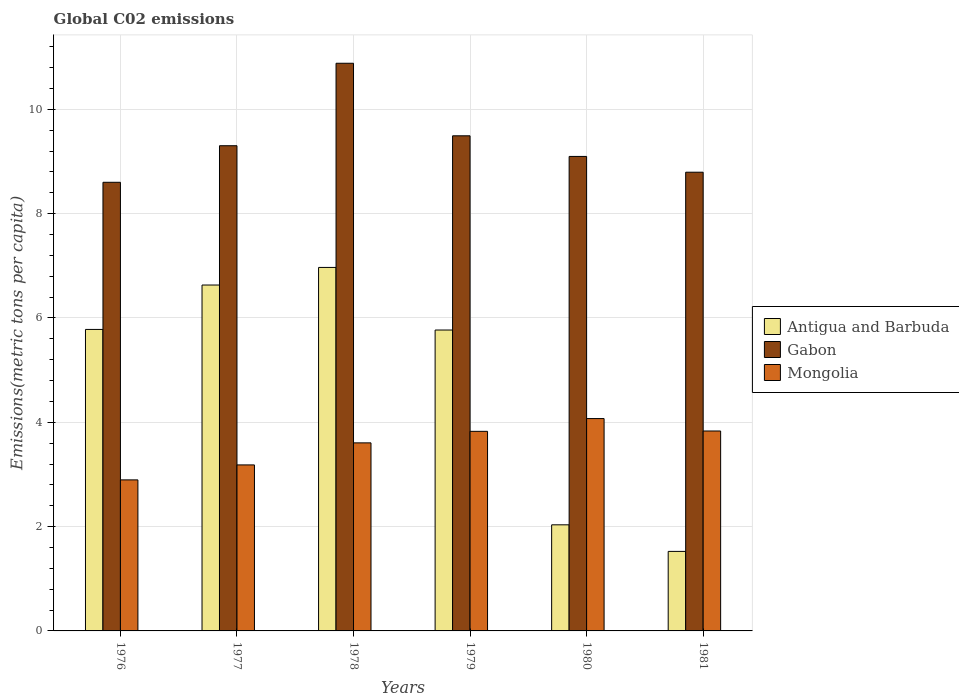What is the label of the 4th group of bars from the left?
Your answer should be very brief. 1979. What is the amount of CO2 emitted in in Mongolia in 1977?
Keep it short and to the point. 3.18. Across all years, what is the maximum amount of CO2 emitted in in Gabon?
Make the answer very short. 10.88. Across all years, what is the minimum amount of CO2 emitted in in Gabon?
Your answer should be compact. 8.6. In which year was the amount of CO2 emitted in in Mongolia maximum?
Offer a very short reply. 1980. In which year was the amount of CO2 emitted in in Gabon minimum?
Your answer should be very brief. 1976. What is the total amount of CO2 emitted in in Mongolia in the graph?
Your response must be concise. 21.42. What is the difference between the amount of CO2 emitted in in Gabon in 1977 and that in 1978?
Provide a succinct answer. -1.58. What is the difference between the amount of CO2 emitted in in Antigua and Barbuda in 1977 and the amount of CO2 emitted in in Mongolia in 1979?
Ensure brevity in your answer.  2.81. What is the average amount of CO2 emitted in in Antigua and Barbuda per year?
Provide a succinct answer. 4.78. In the year 1977, what is the difference between the amount of CO2 emitted in in Gabon and amount of CO2 emitted in in Antigua and Barbuda?
Give a very brief answer. 2.67. In how many years, is the amount of CO2 emitted in in Gabon greater than 3.2 metric tons per capita?
Keep it short and to the point. 6. What is the ratio of the amount of CO2 emitted in in Antigua and Barbuda in 1979 to that in 1980?
Your answer should be compact. 2.84. Is the amount of CO2 emitted in in Antigua and Barbuda in 1979 less than that in 1981?
Your answer should be very brief. No. What is the difference between the highest and the second highest amount of CO2 emitted in in Gabon?
Your answer should be compact. 1.39. What is the difference between the highest and the lowest amount of CO2 emitted in in Mongolia?
Make the answer very short. 1.18. Is the sum of the amount of CO2 emitted in in Mongolia in 1979 and 1981 greater than the maximum amount of CO2 emitted in in Antigua and Barbuda across all years?
Make the answer very short. Yes. What does the 1st bar from the left in 1976 represents?
Your answer should be compact. Antigua and Barbuda. What does the 2nd bar from the right in 1978 represents?
Offer a terse response. Gabon. Is it the case that in every year, the sum of the amount of CO2 emitted in in Gabon and amount of CO2 emitted in in Antigua and Barbuda is greater than the amount of CO2 emitted in in Mongolia?
Provide a short and direct response. Yes. How many bars are there?
Give a very brief answer. 18. Are the values on the major ticks of Y-axis written in scientific E-notation?
Your response must be concise. No. Does the graph contain any zero values?
Your response must be concise. No. Where does the legend appear in the graph?
Keep it short and to the point. Center right. How are the legend labels stacked?
Give a very brief answer. Vertical. What is the title of the graph?
Make the answer very short. Global C02 emissions. Does "Low income" appear as one of the legend labels in the graph?
Ensure brevity in your answer.  No. What is the label or title of the X-axis?
Your answer should be compact. Years. What is the label or title of the Y-axis?
Your answer should be very brief. Emissions(metric tons per capita). What is the Emissions(metric tons per capita) in Antigua and Barbuda in 1976?
Provide a succinct answer. 5.78. What is the Emissions(metric tons per capita) in Gabon in 1976?
Offer a terse response. 8.6. What is the Emissions(metric tons per capita) of Mongolia in 1976?
Provide a succinct answer. 2.9. What is the Emissions(metric tons per capita) in Antigua and Barbuda in 1977?
Offer a terse response. 6.63. What is the Emissions(metric tons per capita) of Gabon in 1977?
Keep it short and to the point. 9.3. What is the Emissions(metric tons per capita) in Mongolia in 1977?
Make the answer very short. 3.18. What is the Emissions(metric tons per capita) in Antigua and Barbuda in 1978?
Your answer should be very brief. 6.97. What is the Emissions(metric tons per capita) of Gabon in 1978?
Provide a succinct answer. 10.88. What is the Emissions(metric tons per capita) of Mongolia in 1978?
Your answer should be compact. 3.61. What is the Emissions(metric tons per capita) of Antigua and Barbuda in 1979?
Your answer should be very brief. 5.77. What is the Emissions(metric tons per capita) in Gabon in 1979?
Your answer should be very brief. 9.49. What is the Emissions(metric tons per capita) in Mongolia in 1979?
Make the answer very short. 3.83. What is the Emissions(metric tons per capita) of Antigua and Barbuda in 1980?
Your response must be concise. 2.03. What is the Emissions(metric tons per capita) in Gabon in 1980?
Make the answer very short. 9.1. What is the Emissions(metric tons per capita) of Mongolia in 1980?
Give a very brief answer. 4.07. What is the Emissions(metric tons per capita) of Antigua and Barbuda in 1981?
Your answer should be very brief. 1.52. What is the Emissions(metric tons per capita) of Gabon in 1981?
Offer a terse response. 8.79. What is the Emissions(metric tons per capita) in Mongolia in 1981?
Ensure brevity in your answer.  3.83. Across all years, what is the maximum Emissions(metric tons per capita) of Antigua and Barbuda?
Give a very brief answer. 6.97. Across all years, what is the maximum Emissions(metric tons per capita) of Gabon?
Ensure brevity in your answer.  10.88. Across all years, what is the maximum Emissions(metric tons per capita) in Mongolia?
Provide a succinct answer. 4.07. Across all years, what is the minimum Emissions(metric tons per capita) in Antigua and Barbuda?
Offer a terse response. 1.52. Across all years, what is the minimum Emissions(metric tons per capita) in Gabon?
Your answer should be very brief. 8.6. Across all years, what is the minimum Emissions(metric tons per capita) of Mongolia?
Your answer should be compact. 2.9. What is the total Emissions(metric tons per capita) of Antigua and Barbuda in the graph?
Make the answer very short. 28.71. What is the total Emissions(metric tons per capita) of Gabon in the graph?
Provide a succinct answer. 56.17. What is the total Emissions(metric tons per capita) of Mongolia in the graph?
Offer a terse response. 21.42. What is the difference between the Emissions(metric tons per capita) of Antigua and Barbuda in 1976 and that in 1977?
Your answer should be very brief. -0.85. What is the difference between the Emissions(metric tons per capita) in Gabon in 1976 and that in 1977?
Provide a short and direct response. -0.7. What is the difference between the Emissions(metric tons per capita) of Mongolia in 1976 and that in 1977?
Provide a succinct answer. -0.29. What is the difference between the Emissions(metric tons per capita) of Antigua and Barbuda in 1976 and that in 1978?
Your answer should be compact. -1.19. What is the difference between the Emissions(metric tons per capita) of Gabon in 1976 and that in 1978?
Provide a short and direct response. -2.28. What is the difference between the Emissions(metric tons per capita) of Mongolia in 1976 and that in 1978?
Offer a very short reply. -0.71. What is the difference between the Emissions(metric tons per capita) of Antigua and Barbuda in 1976 and that in 1979?
Offer a terse response. 0.01. What is the difference between the Emissions(metric tons per capita) of Gabon in 1976 and that in 1979?
Give a very brief answer. -0.89. What is the difference between the Emissions(metric tons per capita) of Mongolia in 1976 and that in 1979?
Your answer should be compact. -0.93. What is the difference between the Emissions(metric tons per capita) in Antigua and Barbuda in 1976 and that in 1980?
Provide a succinct answer. 3.75. What is the difference between the Emissions(metric tons per capita) in Gabon in 1976 and that in 1980?
Your answer should be very brief. -0.5. What is the difference between the Emissions(metric tons per capita) of Mongolia in 1976 and that in 1980?
Your answer should be compact. -1.18. What is the difference between the Emissions(metric tons per capita) of Antigua and Barbuda in 1976 and that in 1981?
Make the answer very short. 4.26. What is the difference between the Emissions(metric tons per capita) in Gabon in 1976 and that in 1981?
Your answer should be compact. -0.19. What is the difference between the Emissions(metric tons per capita) of Mongolia in 1976 and that in 1981?
Your response must be concise. -0.94. What is the difference between the Emissions(metric tons per capita) of Antigua and Barbuda in 1977 and that in 1978?
Your answer should be compact. -0.34. What is the difference between the Emissions(metric tons per capita) in Gabon in 1977 and that in 1978?
Make the answer very short. -1.58. What is the difference between the Emissions(metric tons per capita) in Mongolia in 1977 and that in 1978?
Your answer should be compact. -0.42. What is the difference between the Emissions(metric tons per capita) in Antigua and Barbuda in 1977 and that in 1979?
Make the answer very short. 0.86. What is the difference between the Emissions(metric tons per capita) in Gabon in 1977 and that in 1979?
Offer a terse response. -0.19. What is the difference between the Emissions(metric tons per capita) of Mongolia in 1977 and that in 1979?
Make the answer very short. -0.64. What is the difference between the Emissions(metric tons per capita) in Antigua and Barbuda in 1977 and that in 1980?
Keep it short and to the point. 4.6. What is the difference between the Emissions(metric tons per capita) of Gabon in 1977 and that in 1980?
Offer a very short reply. 0.21. What is the difference between the Emissions(metric tons per capita) of Mongolia in 1977 and that in 1980?
Keep it short and to the point. -0.89. What is the difference between the Emissions(metric tons per capita) of Antigua and Barbuda in 1977 and that in 1981?
Your answer should be very brief. 5.11. What is the difference between the Emissions(metric tons per capita) of Gabon in 1977 and that in 1981?
Keep it short and to the point. 0.51. What is the difference between the Emissions(metric tons per capita) in Mongolia in 1977 and that in 1981?
Ensure brevity in your answer.  -0.65. What is the difference between the Emissions(metric tons per capita) of Antigua and Barbuda in 1978 and that in 1979?
Ensure brevity in your answer.  1.2. What is the difference between the Emissions(metric tons per capita) of Gabon in 1978 and that in 1979?
Offer a terse response. 1.39. What is the difference between the Emissions(metric tons per capita) in Mongolia in 1978 and that in 1979?
Make the answer very short. -0.22. What is the difference between the Emissions(metric tons per capita) of Antigua and Barbuda in 1978 and that in 1980?
Make the answer very short. 4.93. What is the difference between the Emissions(metric tons per capita) in Gabon in 1978 and that in 1980?
Ensure brevity in your answer.  1.79. What is the difference between the Emissions(metric tons per capita) in Mongolia in 1978 and that in 1980?
Ensure brevity in your answer.  -0.47. What is the difference between the Emissions(metric tons per capita) in Antigua and Barbuda in 1978 and that in 1981?
Your answer should be compact. 5.44. What is the difference between the Emissions(metric tons per capita) in Gabon in 1978 and that in 1981?
Give a very brief answer. 2.09. What is the difference between the Emissions(metric tons per capita) of Mongolia in 1978 and that in 1981?
Offer a terse response. -0.23. What is the difference between the Emissions(metric tons per capita) of Antigua and Barbuda in 1979 and that in 1980?
Give a very brief answer. 3.73. What is the difference between the Emissions(metric tons per capita) of Gabon in 1979 and that in 1980?
Give a very brief answer. 0.4. What is the difference between the Emissions(metric tons per capita) in Mongolia in 1979 and that in 1980?
Your response must be concise. -0.24. What is the difference between the Emissions(metric tons per capita) in Antigua and Barbuda in 1979 and that in 1981?
Keep it short and to the point. 4.24. What is the difference between the Emissions(metric tons per capita) in Gabon in 1979 and that in 1981?
Provide a short and direct response. 0.7. What is the difference between the Emissions(metric tons per capita) in Mongolia in 1979 and that in 1981?
Offer a terse response. -0.01. What is the difference between the Emissions(metric tons per capita) in Antigua and Barbuda in 1980 and that in 1981?
Your response must be concise. 0.51. What is the difference between the Emissions(metric tons per capita) of Gabon in 1980 and that in 1981?
Provide a short and direct response. 0.3. What is the difference between the Emissions(metric tons per capita) of Mongolia in 1980 and that in 1981?
Give a very brief answer. 0.24. What is the difference between the Emissions(metric tons per capita) of Antigua and Barbuda in 1976 and the Emissions(metric tons per capita) of Gabon in 1977?
Give a very brief answer. -3.52. What is the difference between the Emissions(metric tons per capita) in Antigua and Barbuda in 1976 and the Emissions(metric tons per capita) in Mongolia in 1977?
Your answer should be very brief. 2.6. What is the difference between the Emissions(metric tons per capita) in Gabon in 1976 and the Emissions(metric tons per capita) in Mongolia in 1977?
Ensure brevity in your answer.  5.42. What is the difference between the Emissions(metric tons per capita) in Antigua and Barbuda in 1976 and the Emissions(metric tons per capita) in Gabon in 1978?
Keep it short and to the point. -5.1. What is the difference between the Emissions(metric tons per capita) in Antigua and Barbuda in 1976 and the Emissions(metric tons per capita) in Mongolia in 1978?
Provide a succinct answer. 2.17. What is the difference between the Emissions(metric tons per capita) in Gabon in 1976 and the Emissions(metric tons per capita) in Mongolia in 1978?
Give a very brief answer. 5. What is the difference between the Emissions(metric tons per capita) of Antigua and Barbuda in 1976 and the Emissions(metric tons per capita) of Gabon in 1979?
Give a very brief answer. -3.71. What is the difference between the Emissions(metric tons per capita) of Antigua and Barbuda in 1976 and the Emissions(metric tons per capita) of Mongolia in 1979?
Provide a succinct answer. 1.95. What is the difference between the Emissions(metric tons per capita) of Gabon in 1976 and the Emissions(metric tons per capita) of Mongolia in 1979?
Your answer should be compact. 4.77. What is the difference between the Emissions(metric tons per capita) in Antigua and Barbuda in 1976 and the Emissions(metric tons per capita) in Gabon in 1980?
Your answer should be compact. -3.32. What is the difference between the Emissions(metric tons per capita) of Antigua and Barbuda in 1976 and the Emissions(metric tons per capita) of Mongolia in 1980?
Your answer should be compact. 1.71. What is the difference between the Emissions(metric tons per capita) in Gabon in 1976 and the Emissions(metric tons per capita) in Mongolia in 1980?
Ensure brevity in your answer.  4.53. What is the difference between the Emissions(metric tons per capita) of Antigua and Barbuda in 1976 and the Emissions(metric tons per capita) of Gabon in 1981?
Your response must be concise. -3.01. What is the difference between the Emissions(metric tons per capita) in Antigua and Barbuda in 1976 and the Emissions(metric tons per capita) in Mongolia in 1981?
Your answer should be very brief. 1.95. What is the difference between the Emissions(metric tons per capita) in Gabon in 1976 and the Emissions(metric tons per capita) in Mongolia in 1981?
Your answer should be very brief. 4.77. What is the difference between the Emissions(metric tons per capita) of Antigua and Barbuda in 1977 and the Emissions(metric tons per capita) of Gabon in 1978?
Offer a terse response. -4.25. What is the difference between the Emissions(metric tons per capita) in Antigua and Barbuda in 1977 and the Emissions(metric tons per capita) in Mongolia in 1978?
Provide a succinct answer. 3.03. What is the difference between the Emissions(metric tons per capita) of Gabon in 1977 and the Emissions(metric tons per capita) of Mongolia in 1978?
Provide a short and direct response. 5.7. What is the difference between the Emissions(metric tons per capita) in Antigua and Barbuda in 1977 and the Emissions(metric tons per capita) in Gabon in 1979?
Your answer should be very brief. -2.86. What is the difference between the Emissions(metric tons per capita) in Antigua and Barbuda in 1977 and the Emissions(metric tons per capita) in Mongolia in 1979?
Provide a succinct answer. 2.81. What is the difference between the Emissions(metric tons per capita) of Gabon in 1977 and the Emissions(metric tons per capita) of Mongolia in 1979?
Offer a terse response. 5.48. What is the difference between the Emissions(metric tons per capita) of Antigua and Barbuda in 1977 and the Emissions(metric tons per capita) of Gabon in 1980?
Give a very brief answer. -2.47. What is the difference between the Emissions(metric tons per capita) in Antigua and Barbuda in 1977 and the Emissions(metric tons per capita) in Mongolia in 1980?
Offer a terse response. 2.56. What is the difference between the Emissions(metric tons per capita) in Gabon in 1977 and the Emissions(metric tons per capita) in Mongolia in 1980?
Your answer should be compact. 5.23. What is the difference between the Emissions(metric tons per capita) of Antigua and Barbuda in 1977 and the Emissions(metric tons per capita) of Gabon in 1981?
Offer a very short reply. -2.16. What is the difference between the Emissions(metric tons per capita) in Antigua and Barbuda in 1977 and the Emissions(metric tons per capita) in Mongolia in 1981?
Offer a terse response. 2.8. What is the difference between the Emissions(metric tons per capita) in Gabon in 1977 and the Emissions(metric tons per capita) in Mongolia in 1981?
Make the answer very short. 5.47. What is the difference between the Emissions(metric tons per capita) of Antigua and Barbuda in 1978 and the Emissions(metric tons per capita) of Gabon in 1979?
Provide a short and direct response. -2.52. What is the difference between the Emissions(metric tons per capita) in Antigua and Barbuda in 1978 and the Emissions(metric tons per capita) in Mongolia in 1979?
Give a very brief answer. 3.14. What is the difference between the Emissions(metric tons per capita) in Gabon in 1978 and the Emissions(metric tons per capita) in Mongolia in 1979?
Ensure brevity in your answer.  7.06. What is the difference between the Emissions(metric tons per capita) of Antigua and Barbuda in 1978 and the Emissions(metric tons per capita) of Gabon in 1980?
Your response must be concise. -2.13. What is the difference between the Emissions(metric tons per capita) of Antigua and Barbuda in 1978 and the Emissions(metric tons per capita) of Mongolia in 1980?
Give a very brief answer. 2.9. What is the difference between the Emissions(metric tons per capita) of Gabon in 1978 and the Emissions(metric tons per capita) of Mongolia in 1980?
Keep it short and to the point. 6.81. What is the difference between the Emissions(metric tons per capita) in Antigua and Barbuda in 1978 and the Emissions(metric tons per capita) in Gabon in 1981?
Offer a terse response. -1.83. What is the difference between the Emissions(metric tons per capita) in Antigua and Barbuda in 1978 and the Emissions(metric tons per capita) in Mongolia in 1981?
Make the answer very short. 3.14. What is the difference between the Emissions(metric tons per capita) of Gabon in 1978 and the Emissions(metric tons per capita) of Mongolia in 1981?
Offer a very short reply. 7.05. What is the difference between the Emissions(metric tons per capita) of Antigua and Barbuda in 1979 and the Emissions(metric tons per capita) of Gabon in 1980?
Ensure brevity in your answer.  -3.33. What is the difference between the Emissions(metric tons per capita) in Antigua and Barbuda in 1979 and the Emissions(metric tons per capita) in Mongolia in 1980?
Ensure brevity in your answer.  1.7. What is the difference between the Emissions(metric tons per capita) of Gabon in 1979 and the Emissions(metric tons per capita) of Mongolia in 1980?
Provide a succinct answer. 5.42. What is the difference between the Emissions(metric tons per capita) of Antigua and Barbuda in 1979 and the Emissions(metric tons per capita) of Gabon in 1981?
Make the answer very short. -3.03. What is the difference between the Emissions(metric tons per capita) of Antigua and Barbuda in 1979 and the Emissions(metric tons per capita) of Mongolia in 1981?
Make the answer very short. 1.94. What is the difference between the Emissions(metric tons per capita) of Gabon in 1979 and the Emissions(metric tons per capita) of Mongolia in 1981?
Make the answer very short. 5.66. What is the difference between the Emissions(metric tons per capita) in Antigua and Barbuda in 1980 and the Emissions(metric tons per capita) in Gabon in 1981?
Your answer should be very brief. -6.76. What is the difference between the Emissions(metric tons per capita) in Antigua and Barbuda in 1980 and the Emissions(metric tons per capita) in Mongolia in 1981?
Offer a very short reply. -1.8. What is the difference between the Emissions(metric tons per capita) in Gabon in 1980 and the Emissions(metric tons per capita) in Mongolia in 1981?
Your response must be concise. 5.26. What is the average Emissions(metric tons per capita) in Antigua and Barbuda per year?
Offer a very short reply. 4.78. What is the average Emissions(metric tons per capita) of Gabon per year?
Your answer should be compact. 9.36. What is the average Emissions(metric tons per capita) in Mongolia per year?
Your response must be concise. 3.57. In the year 1976, what is the difference between the Emissions(metric tons per capita) of Antigua and Barbuda and Emissions(metric tons per capita) of Gabon?
Offer a very short reply. -2.82. In the year 1976, what is the difference between the Emissions(metric tons per capita) of Antigua and Barbuda and Emissions(metric tons per capita) of Mongolia?
Offer a very short reply. 2.88. In the year 1976, what is the difference between the Emissions(metric tons per capita) in Gabon and Emissions(metric tons per capita) in Mongolia?
Your answer should be very brief. 5.71. In the year 1977, what is the difference between the Emissions(metric tons per capita) in Antigua and Barbuda and Emissions(metric tons per capita) in Gabon?
Keep it short and to the point. -2.67. In the year 1977, what is the difference between the Emissions(metric tons per capita) in Antigua and Barbuda and Emissions(metric tons per capita) in Mongolia?
Make the answer very short. 3.45. In the year 1977, what is the difference between the Emissions(metric tons per capita) in Gabon and Emissions(metric tons per capita) in Mongolia?
Give a very brief answer. 6.12. In the year 1978, what is the difference between the Emissions(metric tons per capita) in Antigua and Barbuda and Emissions(metric tons per capita) in Gabon?
Your response must be concise. -3.91. In the year 1978, what is the difference between the Emissions(metric tons per capita) of Antigua and Barbuda and Emissions(metric tons per capita) of Mongolia?
Offer a terse response. 3.36. In the year 1978, what is the difference between the Emissions(metric tons per capita) of Gabon and Emissions(metric tons per capita) of Mongolia?
Ensure brevity in your answer.  7.28. In the year 1979, what is the difference between the Emissions(metric tons per capita) in Antigua and Barbuda and Emissions(metric tons per capita) in Gabon?
Offer a very short reply. -3.72. In the year 1979, what is the difference between the Emissions(metric tons per capita) in Antigua and Barbuda and Emissions(metric tons per capita) in Mongolia?
Give a very brief answer. 1.94. In the year 1979, what is the difference between the Emissions(metric tons per capita) of Gabon and Emissions(metric tons per capita) of Mongolia?
Your answer should be compact. 5.67. In the year 1980, what is the difference between the Emissions(metric tons per capita) of Antigua and Barbuda and Emissions(metric tons per capita) of Gabon?
Offer a terse response. -7.06. In the year 1980, what is the difference between the Emissions(metric tons per capita) of Antigua and Barbuda and Emissions(metric tons per capita) of Mongolia?
Offer a very short reply. -2.04. In the year 1980, what is the difference between the Emissions(metric tons per capita) in Gabon and Emissions(metric tons per capita) in Mongolia?
Provide a short and direct response. 5.03. In the year 1981, what is the difference between the Emissions(metric tons per capita) of Antigua and Barbuda and Emissions(metric tons per capita) of Gabon?
Your answer should be compact. -7.27. In the year 1981, what is the difference between the Emissions(metric tons per capita) of Antigua and Barbuda and Emissions(metric tons per capita) of Mongolia?
Provide a short and direct response. -2.31. In the year 1981, what is the difference between the Emissions(metric tons per capita) of Gabon and Emissions(metric tons per capita) of Mongolia?
Your answer should be compact. 4.96. What is the ratio of the Emissions(metric tons per capita) in Antigua and Barbuda in 1976 to that in 1977?
Give a very brief answer. 0.87. What is the ratio of the Emissions(metric tons per capita) in Gabon in 1976 to that in 1977?
Your response must be concise. 0.92. What is the ratio of the Emissions(metric tons per capita) in Mongolia in 1976 to that in 1977?
Keep it short and to the point. 0.91. What is the ratio of the Emissions(metric tons per capita) in Antigua and Barbuda in 1976 to that in 1978?
Offer a terse response. 0.83. What is the ratio of the Emissions(metric tons per capita) of Gabon in 1976 to that in 1978?
Offer a terse response. 0.79. What is the ratio of the Emissions(metric tons per capita) in Mongolia in 1976 to that in 1978?
Offer a terse response. 0.8. What is the ratio of the Emissions(metric tons per capita) in Gabon in 1976 to that in 1979?
Offer a terse response. 0.91. What is the ratio of the Emissions(metric tons per capita) of Mongolia in 1976 to that in 1979?
Make the answer very short. 0.76. What is the ratio of the Emissions(metric tons per capita) in Antigua and Barbuda in 1976 to that in 1980?
Make the answer very short. 2.84. What is the ratio of the Emissions(metric tons per capita) of Gabon in 1976 to that in 1980?
Offer a terse response. 0.95. What is the ratio of the Emissions(metric tons per capita) of Mongolia in 1976 to that in 1980?
Your answer should be very brief. 0.71. What is the ratio of the Emissions(metric tons per capita) of Antigua and Barbuda in 1976 to that in 1981?
Your response must be concise. 3.79. What is the ratio of the Emissions(metric tons per capita) of Mongolia in 1976 to that in 1981?
Your answer should be very brief. 0.76. What is the ratio of the Emissions(metric tons per capita) of Antigua and Barbuda in 1977 to that in 1978?
Ensure brevity in your answer.  0.95. What is the ratio of the Emissions(metric tons per capita) in Gabon in 1977 to that in 1978?
Your response must be concise. 0.85. What is the ratio of the Emissions(metric tons per capita) of Mongolia in 1977 to that in 1978?
Offer a terse response. 0.88. What is the ratio of the Emissions(metric tons per capita) of Antigua and Barbuda in 1977 to that in 1979?
Keep it short and to the point. 1.15. What is the ratio of the Emissions(metric tons per capita) of Gabon in 1977 to that in 1979?
Give a very brief answer. 0.98. What is the ratio of the Emissions(metric tons per capita) in Mongolia in 1977 to that in 1979?
Make the answer very short. 0.83. What is the ratio of the Emissions(metric tons per capita) in Antigua and Barbuda in 1977 to that in 1980?
Offer a very short reply. 3.26. What is the ratio of the Emissions(metric tons per capita) in Gabon in 1977 to that in 1980?
Make the answer very short. 1.02. What is the ratio of the Emissions(metric tons per capita) of Mongolia in 1977 to that in 1980?
Provide a succinct answer. 0.78. What is the ratio of the Emissions(metric tons per capita) in Antigua and Barbuda in 1977 to that in 1981?
Ensure brevity in your answer.  4.35. What is the ratio of the Emissions(metric tons per capita) of Gabon in 1977 to that in 1981?
Make the answer very short. 1.06. What is the ratio of the Emissions(metric tons per capita) of Mongolia in 1977 to that in 1981?
Your answer should be compact. 0.83. What is the ratio of the Emissions(metric tons per capita) in Antigua and Barbuda in 1978 to that in 1979?
Your answer should be very brief. 1.21. What is the ratio of the Emissions(metric tons per capita) in Gabon in 1978 to that in 1979?
Make the answer very short. 1.15. What is the ratio of the Emissions(metric tons per capita) of Mongolia in 1978 to that in 1979?
Offer a terse response. 0.94. What is the ratio of the Emissions(metric tons per capita) in Antigua and Barbuda in 1978 to that in 1980?
Provide a short and direct response. 3.43. What is the ratio of the Emissions(metric tons per capita) in Gabon in 1978 to that in 1980?
Keep it short and to the point. 1.2. What is the ratio of the Emissions(metric tons per capita) of Mongolia in 1978 to that in 1980?
Keep it short and to the point. 0.89. What is the ratio of the Emissions(metric tons per capita) in Antigua and Barbuda in 1978 to that in 1981?
Keep it short and to the point. 4.57. What is the ratio of the Emissions(metric tons per capita) in Gabon in 1978 to that in 1981?
Provide a short and direct response. 1.24. What is the ratio of the Emissions(metric tons per capita) of Mongolia in 1978 to that in 1981?
Your answer should be very brief. 0.94. What is the ratio of the Emissions(metric tons per capita) in Antigua and Barbuda in 1979 to that in 1980?
Offer a terse response. 2.84. What is the ratio of the Emissions(metric tons per capita) of Gabon in 1979 to that in 1980?
Offer a terse response. 1.04. What is the ratio of the Emissions(metric tons per capita) in Mongolia in 1979 to that in 1980?
Offer a very short reply. 0.94. What is the ratio of the Emissions(metric tons per capita) of Antigua and Barbuda in 1979 to that in 1981?
Make the answer very short. 3.78. What is the ratio of the Emissions(metric tons per capita) in Gabon in 1979 to that in 1981?
Provide a short and direct response. 1.08. What is the ratio of the Emissions(metric tons per capita) in Mongolia in 1979 to that in 1981?
Ensure brevity in your answer.  1. What is the ratio of the Emissions(metric tons per capita) in Antigua and Barbuda in 1980 to that in 1981?
Provide a short and direct response. 1.33. What is the ratio of the Emissions(metric tons per capita) in Gabon in 1980 to that in 1981?
Provide a succinct answer. 1.03. What is the ratio of the Emissions(metric tons per capita) in Mongolia in 1980 to that in 1981?
Offer a terse response. 1.06. What is the difference between the highest and the second highest Emissions(metric tons per capita) of Antigua and Barbuda?
Give a very brief answer. 0.34. What is the difference between the highest and the second highest Emissions(metric tons per capita) in Gabon?
Your answer should be very brief. 1.39. What is the difference between the highest and the second highest Emissions(metric tons per capita) in Mongolia?
Offer a terse response. 0.24. What is the difference between the highest and the lowest Emissions(metric tons per capita) of Antigua and Barbuda?
Your response must be concise. 5.44. What is the difference between the highest and the lowest Emissions(metric tons per capita) of Gabon?
Your answer should be compact. 2.28. What is the difference between the highest and the lowest Emissions(metric tons per capita) in Mongolia?
Provide a short and direct response. 1.18. 